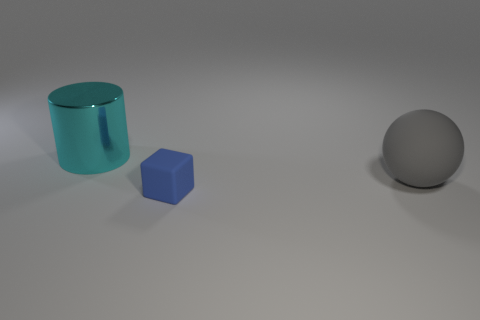Are there any other things that have the same material as the cyan cylinder?
Keep it short and to the point. No. Is there anything else that is the same size as the cube?
Keep it short and to the point. No. Are there more gray matte spheres than big cyan rubber blocks?
Provide a succinct answer. Yes. The thing that is in front of the big cyan shiny cylinder and behind the blue block has what shape?
Provide a succinct answer. Sphere. Are any big matte cubes visible?
Offer a terse response. No. There is a object that is on the left side of the object in front of the big object that is in front of the large shiny cylinder; what shape is it?
Provide a short and direct response. Cylinder. How many blue matte things are the same shape as the gray matte object?
Provide a short and direct response. 0. Is the color of the object behind the gray object the same as the thing that is in front of the large gray thing?
Keep it short and to the point. No. What material is the sphere that is the same size as the metallic thing?
Make the answer very short. Rubber. Are there any matte balls that have the same size as the cube?
Make the answer very short. No. 